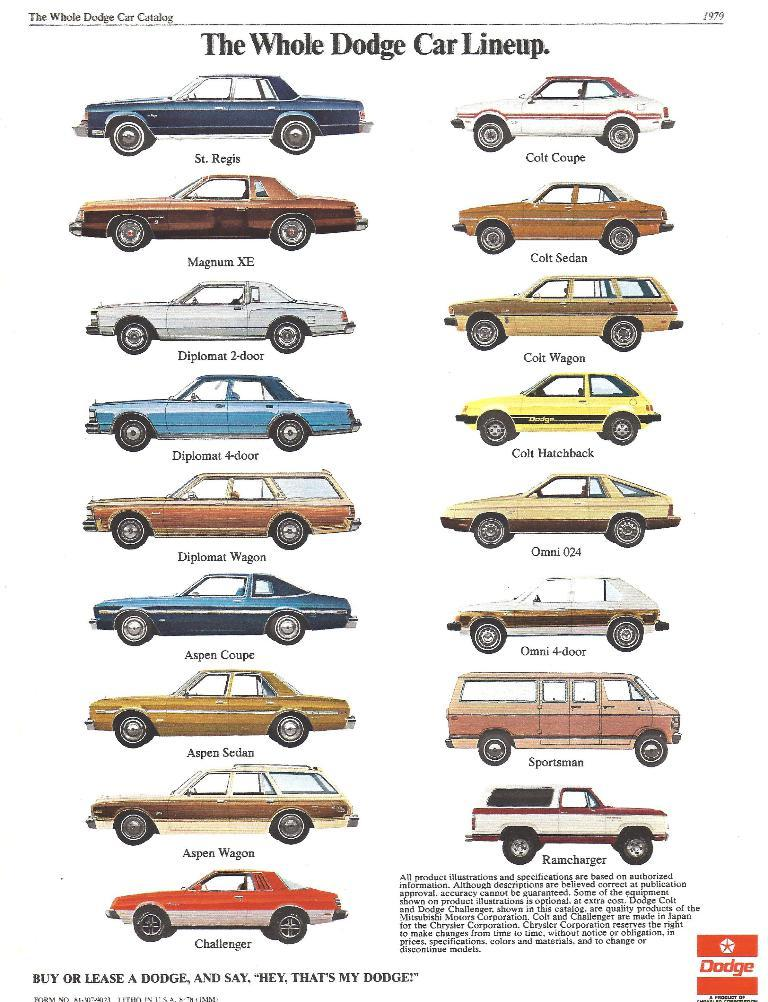What is the main subject of the image? The main subject of the image is a group of cars. Can you describe any specific details about the cars? Yes, there is text visible on the cars. What type of crown can be seen on the cattle in the image? There are no cattle or crowns present in the image; it features a group of cars with text on them. 